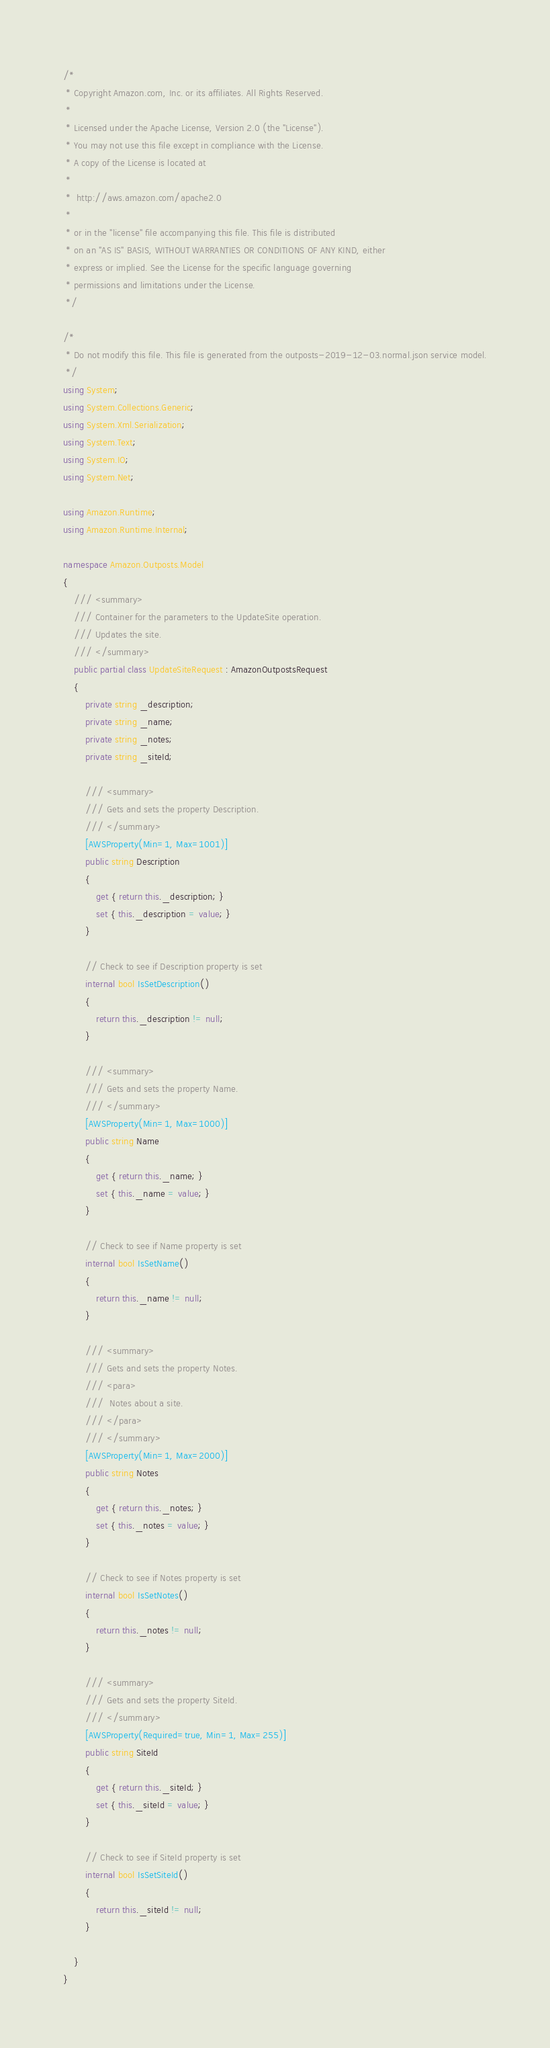Convert code to text. <code><loc_0><loc_0><loc_500><loc_500><_C#_>/*
 * Copyright Amazon.com, Inc. or its affiliates. All Rights Reserved.
 * 
 * Licensed under the Apache License, Version 2.0 (the "License").
 * You may not use this file except in compliance with the License.
 * A copy of the License is located at
 * 
 *  http://aws.amazon.com/apache2.0
 * 
 * or in the "license" file accompanying this file. This file is distributed
 * on an "AS IS" BASIS, WITHOUT WARRANTIES OR CONDITIONS OF ANY KIND, either
 * express or implied. See the License for the specific language governing
 * permissions and limitations under the License.
 */

/*
 * Do not modify this file. This file is generated from the outposts-2019-12-03.normal.json service model.
 */
using System;
using System.Collections.Generic;
using System.Xml.Serialization;
using System.Text;
using System.IO;
using System.Net;

using Amazon.Runtime;
using Amazon.Runtime.Internal;

namespace Amazon.Outposts.Model
{
    /// <summary>
    /// Container for the parameters to the UpdateSite operation.
    /// Updates the site.
    /// </summary>
    public partial class UpdateSiteRequest : AmazonOutpostsRequest
    {
        private string _description;
        private string _name;
        private string _notes;
        private string _siteId;

        /// <summary>
        /// Gets and sets the property Description.
        /// </summary>
        [AWSProperty(Min=1, Max=1001)]
        public string Description
        {
            get { return this._description; }
            set { this._description = value; }
        }

        // Check to see if Description property is set
        internal bool IsSetDescription()
        {
            return this._description != null;
        }

        /// <summary>
        /// Gets and sets the property Name.
        /// </summary>
        [AWSProperty(Min=1, Max=1000)]
        public string Name
        {
            get { return this._name; }
            set { this._name = value; }
        }

        // Check to see if Name property is set
        internal bool IsSetName()
        {
            return this._name != null;
        }

        /// <summary>
        /// Gets and sets the property Notes. 
        /// <para>
        ///  Notes about a site. 
        /// </para>
        /// </summary>
        [AWSProperty(Min=1, Max=2000)]
        public string Notes
        {
            get { return this._notes; }
            set { this._notes = value; }
        }

        // Check to see if Notes property is set
        internal bool IsSetNotes()
        {
            return this._notes != null;
        }

        /// <summary>
        /// Gets and sets the property SiteId.
        /// </summary>
        [AWSProperty(Required=true, Min=1, Max=255)]
        public string SiteId
        {
            get { return this._siteId; }
            set { this._siteId = value; }
        }

        // Check to see if SiteId property is set
        internal bool IsSetSiteId()
        {
            return this._siteId != null;
        }

    }
}</code> 